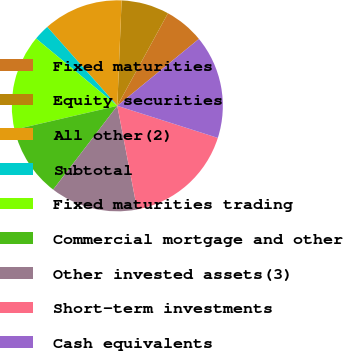Convert chart to OTSL. <chart><loc_0><loc_0><loc_500><loc_500><pie_chart><fcel>Fixed maturities<fcel>Equity securities<fcel>All other(2)<fcel>Subtotal<fcel>Fixed maturities trading<fcel>Commercial mortgage and other<fcel>Other invested assets(3)<fcel>Short-term investments<fcel>Cash equivalents<nl><fcel>6.1%<fcel>7.32%<fcel>12.2%<fcel>2.44%<fcel>14.63%<fcel>10.98%<fcel>13.41%<fcel>17.07%<fcel>15.85%<nl></chart> 